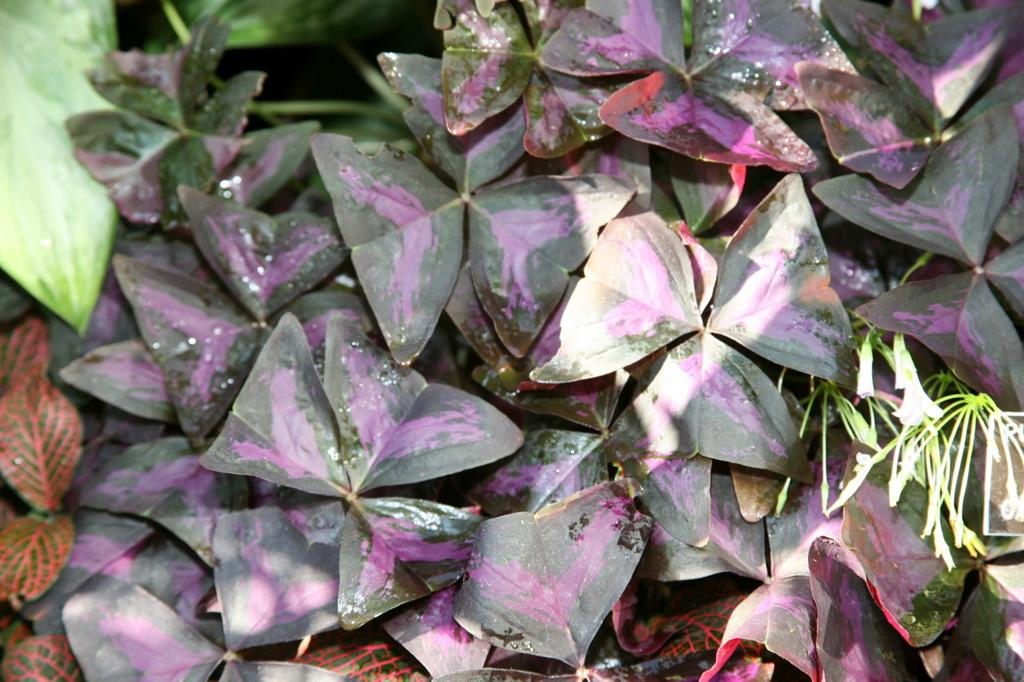What type of plants are visible in the image? There are flowers and leaves in the image. What can be inferred about the lighting conditions in the image? The background of the image is dark, suggesting that it might be nighttime or the scene is indoors with low lighting. What type of zephyr is blowing through the flowers in the image? There is no zephyr present in the image, as a zephyr refers to a gentle breeze, and the image only shows flowers and leaves. 